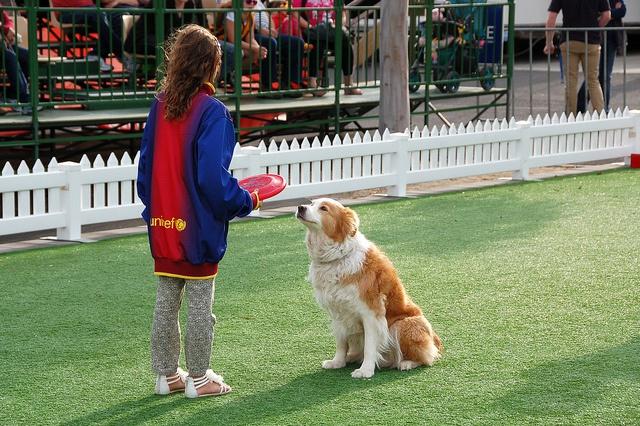Describe the objects in this image and their specific colors. I can see people in black, navy, brown, and gray tones, dog in black, darkgray, tan, brown, and lightgray tones, people in black, gray, and maroon tones, bench in black, gray, darkgray, and darkgreen tones, and people in black, maroon, gray, and darkgreen tones in this image. 